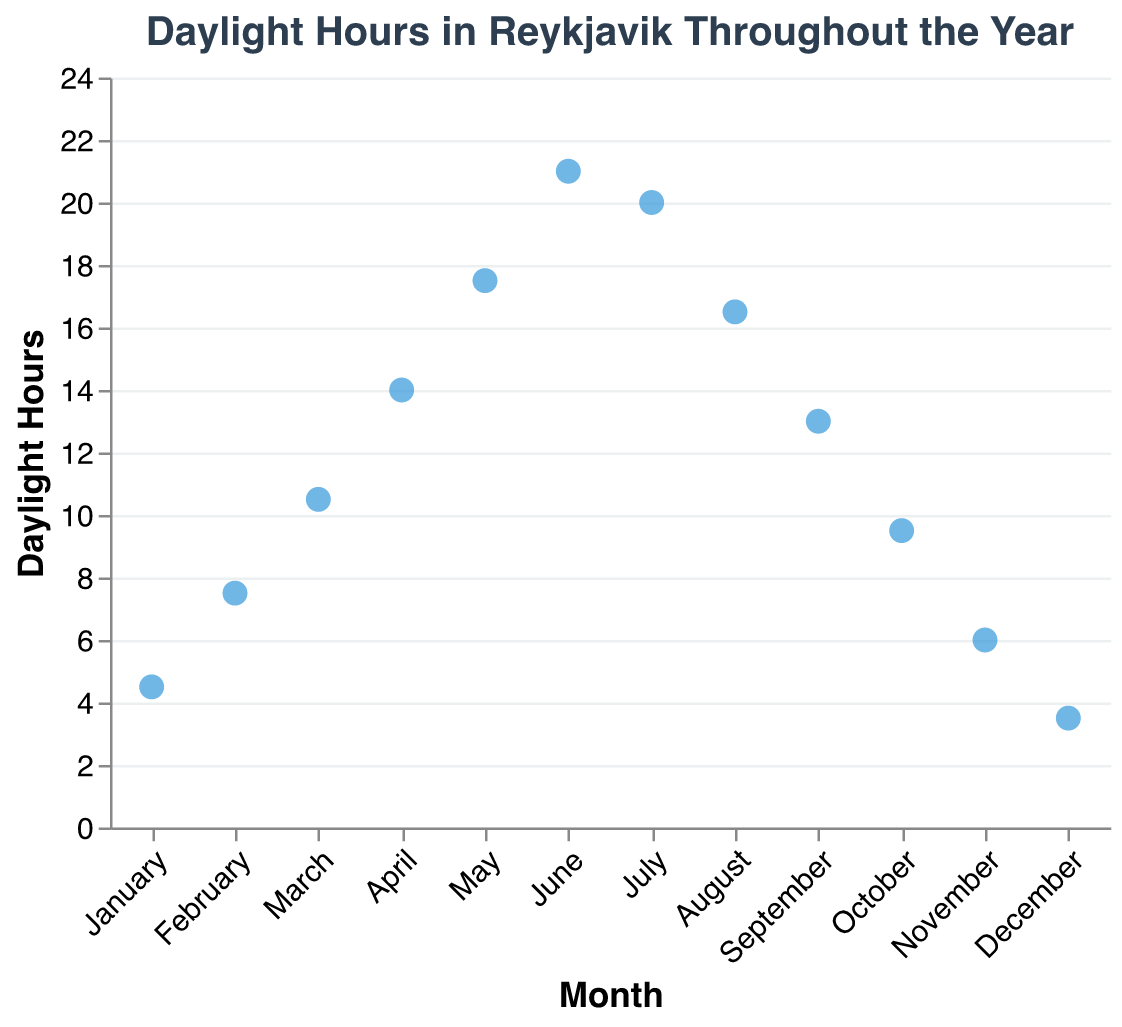What's the title of the figure? The title is positioned at the top of the figure and provides a summary of the content of the plot, indicating that it shows the daylight hours in Reykjavik throughout the year.
Answer: Daylight Hours in Reykjavik Throughout the Year What are the daylight hours in June? By looking at the vertical position of the June data point on the plot, we can see it aligns with 21 hours on the y-axis.
Answer: 21 In which month is the daylight the shortest? The lowest point on the y-axis represents the shortest daylight, which corresponds to December at 3.5 hours.
Answer: December How many hours of daylight are there in November? The data point for November on the plot corresponds to 6 hours on the y-axis.
Answer: 6 What is the difference in daylight hours between January and July? The data points show January has 4.5 hours and July has 20 hours. Subtract 4.5 from 20.
Answer: 15.5 In which month do we see the largest increase in daylight hours compared to the previous month? Comparing the daylight hours month by month, the largest increase is observed between April (14 hours) and May (17.5 hours), an increase of 3.5 hours.
Answer: May Which months have more than 15 hours of daylight? Identifying the points above 15 hours on the y-axis shows May, June, July, and August exceed this threshold.
Answer: May, June, July, August What is the average daylight hours for the summer months (June, July, August)? Sum the hours for June (21), July (20), and August (16.5) and divide by 3. This is (21 + 20 + 16.5)/3.
Answer: 19.17 By how many hours does the daylight in April exceed that in October? April has 14 daylight hours and October has 9.5. Subtract 9.5 from 14.
Answer: 4.5 Which month experiences the fastest decrease in daylight hours from the previous month? Comparing the decreases month-to-month, the largest decrease is from July (20 hours) to August (16.5 hours), a decrease of 3.5 hours.
Answer: August 